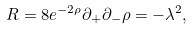Convert formula to latex. <formula><loc_0><loc_0><loc_500><loc_500>R = 8 e ^ { - 2 \rho } \partial _ { + } \partial _ { - } \rho = - \lambda ^ { 2 } ,</formula> 